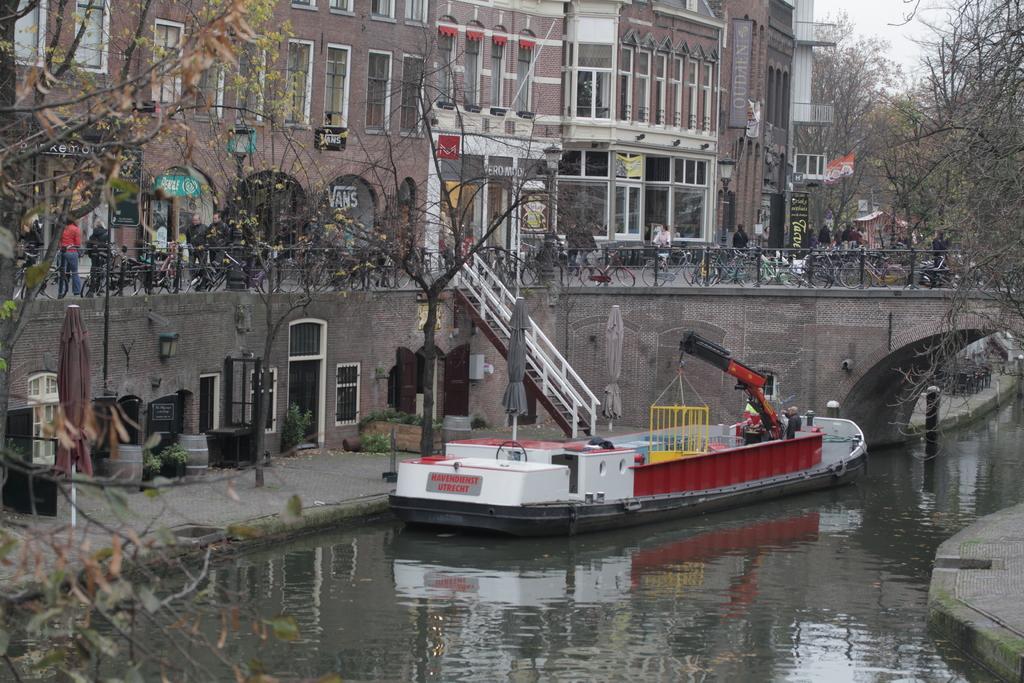How would you summarize this image in a sentence or two? In the foreground of this picture, there is a boat in the water. In the background, we can see stairs, trees, windows, doors, wall, lights, umbrella, railing, bicycles, building, flag and the sky. 